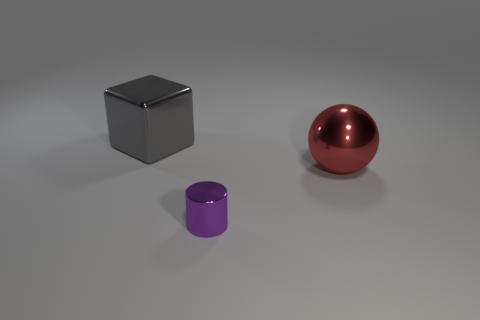Add 2 red objects. How many objects exist? 5 Subtract all cylinders. How many objects are left? 2 Subtract all gray cubes. Subtract all red metallic objects. How many objects are left? 1 Add 1 big shiny blocks. How many big shiny blocks are left? 2 Add 2 shiny cylinders. How many shiny cylinders exist? 3 Subtract 0 yellow cylinders. How many objects are left? 3 